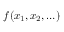<formula> <loc_0><loc_0><loc_500><loc_500>f ( x _ { 1 } , x _ { 2 } , \dots )</formula> 